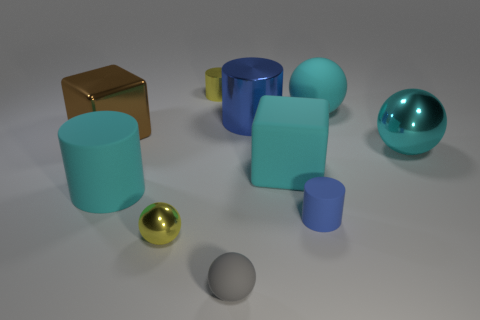There is a large metal object that is the same color as the large matte cube; what shape is it?
Provide a succinct answer. Sphere. Is the shape of the large blue metallic object the same as the blue object in front of the metal cube?
Provide a succinct answer. Yes. There is a cyan ball that is made of the same material as the yellow cylinder; what is its size?
Give a very brief answer. Large. Are there any other things that have the same color as the large metal cylinder?
Your answer should be compact. Yes. What is the tiny cylinder that is on the right side of the block that is to the right of the big cylinder in front of the brown cube made of?
Make the answer very short. Rubber. How many metallic objects are small blue objects or large yellow things?
Your response must be concise. 0. Do the big matte cylinder and the small shiny cylinder have the same color?
Provide a succinct answer. No. Is there anything else that is made of the same material as the brown object?
Ensure brevity in your answer.  Yes. How many things are large cyan things or cyan objects to the right of the cyan matte sphere?
Provide a short and direct response. 4. Is the size of the blue object that is to the right of the blue metal thing the same as the large metallic cube?
Give a very brief answer. No. 